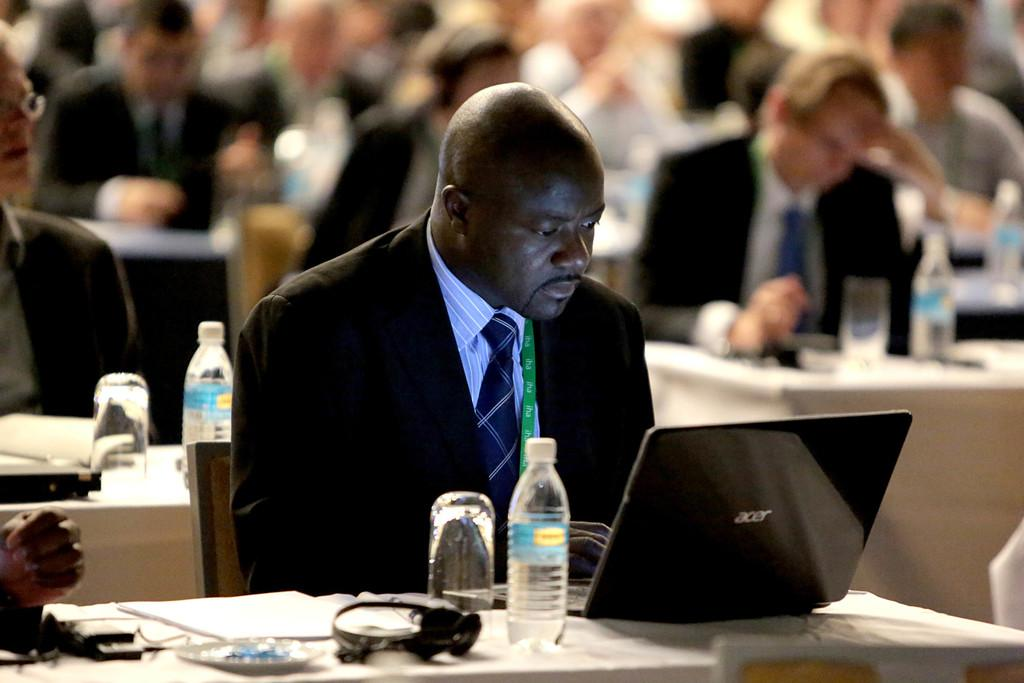Who is present in the image? There are people in the image. What are the people doing in the image? The people are sitting at tables and looking at their laptops. What type of stew is being served at the table in the image? There is no stew present in the image; the people are looking at their laptops while sitting at tables. 